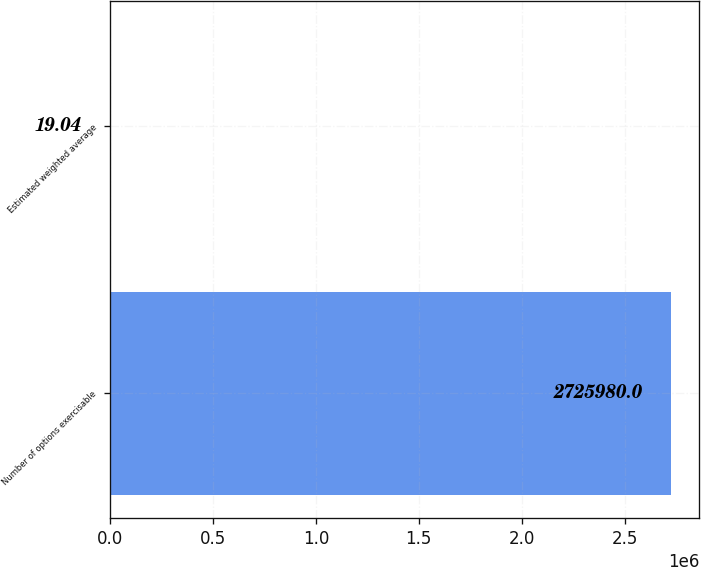Convert chart to OTSL. <chart><loc_0><loc_0><loc_500><loc_500><bar_chart><fcel>Number of options exercisable<fcel>Estimated weighted average<nl><fcel>2.72598e+06<fcel>19.04<nl></chart> 